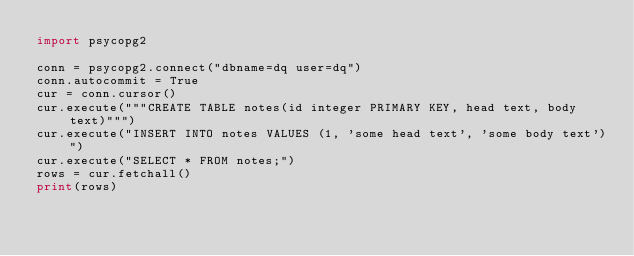<code> <loc_0><loc_0><loc_500><loc_500><_Python_>import psycopg2

conn = psycopg2.connect("dbname=dq user=dq")
conn.autocommit = True
cur = conn.cursor()
cur.execute("""CREATE TABLE notes(id integer PRIMARY KEY, head text, body text)""")
cur.execute("INSERT INTO notes VALUES (1, 'some head text', 'some body text')")
cur.execute("SELECT * FROM notes;")
rows = cur.fetchall()
print(rows)
</code> 